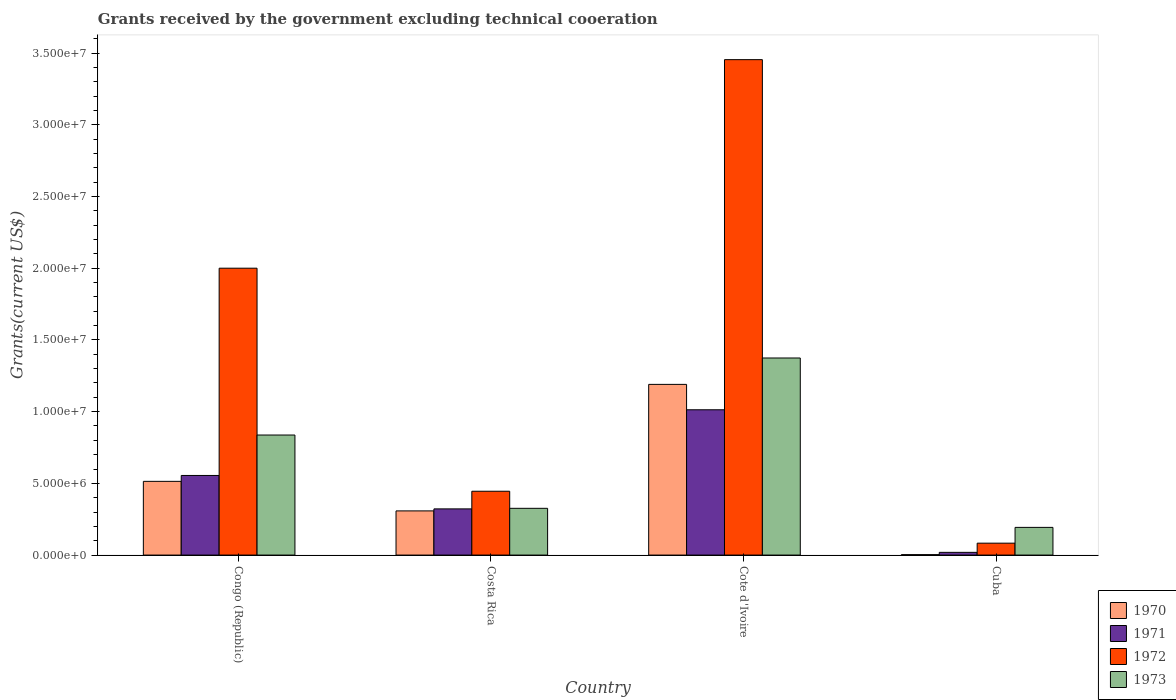Are the number of bars per tick equal to the number of legend labels?
Give a very brief answer. Yes. How many bars are there on the 4th tick from the right?
Your answer should be very brief. 4. What is the label of the 4th group of bars from the left?
Make the answer very short. Cuba. In how many cases, is the number of bars for a given country not equal to the number of legend labels?
Give a very brief answer. 0. What is the total grants received by the government in 1972 in Congo (Republic)?
Provide a short and direct response. 2.00e+07. Across all countries, what is the maximum total grants received by the government in 1972?
Offer a terse response. 3.45e+07. Across all countries, what is the minimum total grants received by the government in 1971?
Your answer should be compact. 1.90e+05. In which country was the total grants received by the government in 1971 maximum?
Make the answer very short. Cote d'Ivoire. In which country was the total grants received by the government in 1970 minimum?
Your answer should be compact. Cuba. What is the total total grants received by the government in 1970 in the graph?
Ensure brevity in your answer.  2.02e+07. What is the difference between the total grants received by the government in 1971 in Costa Rica and that in Cuba?
Your response must be concise. 3.03e+06. What is the difference between the total grants received by the government in 1972 in Costa Rica and the total grants received by the government in 1973 in Cuba?
Make the answer very short. 2.52e+06. What is the average total grants received by the government in 1970 per country?
Give a very brief answer. 5.04e+06. What is the difference between the total grants received by the government of/in 1972 and total grants received by the government of/in 1970 in Congo (Republic)?
Your response must be concise. 1.49e+07. What is the ratio of the total grants received by the government in 1972 in Costa Rica to that in Cuba?
Provide a succinct answer. 5.36. Is the total grants received by the government in 1973 in Congo (Republic) less than that in Costa Rica?
Make the answer very short. No. What is the difference between the highest and the second highest total grants received by the government in 1972?
Keep it short and to the point. 1.45e+07. What is the difference between the highest and the lowest total grants received by the government in 1972?
Keep it short and to the point. 3.37e+07. What does the 3rd bar from the left in Cuba represents?
Give a very brief answer. 1972. What does the 2nd bar from the right in Cote d'Ivoire represents?
Provide a succinct answer. 1972. Is it the case that in every country, the sum of the total grants received by the government in 1971 and total grants received by the government in 1973 is greater than the total grants received by the government in 1972?
Provide a short and direct response. No. How many bars are there?
Ensure brevity in your answer.  16. Are all the bars in the graph horizontal?
Provide a short and direct response. No. How many countries are there in the graph?
Your answer should be very brief. 4. Does the graph contain any zero values?
Provide a succinct answer. No. Does the graph contain grids?
Ensure brevity in your answer.  No. Where does the legend appear in the graph?
Offer a very short reply. Bottom right. How many legend labels are there?
Your answer should be compact. 4. How are the legend labels stacked?
Your answer should be compact. Vertical. What is the title of the graph?
Offer a terse response. Grants received by the government excluding technical cooeration. Does "2002" appear as one of the legend labels in the graph?
Provide a succinct answer. No. What is the label or title of the Y-axis?
Keep it short and to the point. Grants(current US$). What is the Grants(current US$) in 1970 in Congo (Republic)?
Offer a very short reply. 5.14e+06. What is the Grants(current US$) of 1971 in Congo (Republic)?
Make the answer very short. 5.55e+06. What is the Grants(current US$) of 1973 in Congo (Republic)?
Offer a very short reply. 8.37e+06. What is the Grants(current US$) in 1970 in Costa Rica?
Make the answer very short. 3.08e+06. What is the Grants(current US$) in 1971 in Costa Rica?
Keep it short and to the point. 3.22e+06. What is the Grants(current US$) in 1972 in Costa Rica?
Provide a short and direct response. 4.45e+06. What is the Grants(current US$) of 1973 in Costa Rica?
Provide a short and direct response. 3.26e+06. What is the Grants(current US$) of 1970 in Cote d'Ivoire?
Your answer should be compact. 1.19e+07. What is the Grants(current US$) of 1971 in Cote d'Ivoire?
Keep it short and to the point. 1.01e+07. What is the Grants(current US$) of 1972 in Cote d'Ivoire?
Offer a very short reply. 3.45e+07. What is the Grants(current US$) in 1973 in Cote d'Ivoire?
Offer a very short reply. 1.37e+07. What is the Grants(current US$) of 1971 in Cuba?
Offer a very short reply. 1.90e+05. What is the Grants(current US$) in 1972 in Cuba?
Keep it short and to the point. 8.30e+05. What is the Grants(current US$) in 1973 in Cuba?
Your response must be concise. 1.93e+06. Across all countries, what is the maximum Grants(current US$) in 1970?
Keep it short and to the point. 1.19e+07. Across all countries, what is the maximum Grants(current US$) of 1971?
Ensure brevity in your answer.  1.01e+07. Across all countries, what is the maximum Grants(current US$) of 1972?
Your answer should be compact. 3.45e+07. Across all countries, what is the maximum Grants(current US$) in 1973?
Your answer should be very brief. 1.37e+07. Across all countries, what is the minimum Grants(current US$) of 1971?
Keep it short and to the point. 1.90e+05. Across all countries, what is the minimum Grants(current US$) of 1972?
Provide a succinct answer. 8.30e+05. Across all countries, what is the minimum Grants(current US$) of 1973?
Give a very brief answer. 1.93e+06. What is the total Grants(current US$) in 1970 in the graph?
Keep it short and to the point. 2.02e+07. What is the total Grants(current US$) in 1971 in the graph?
Provide a succinct answer. 1.91e+07. What is the total Grants(current US$) in 1972 in the graph?
Offer a terse response. 5.98e+07. What is the total Grants(current US$) in 1973 in the graph?
Your answer should be compact. 2.73e+07. What is the difference between the Grants(current US$) in 1970 in Congo (Republic) and that in Costa Rica?
Your answer should be very brief. 2.06e+06. What is the difference between the Grants(current US$) of 1971 in Congo (Republic) and that in Costa Rica?
Your answer should be very brief. 2.33e+06. What is the difference between the Grants(current US$) of 1972 in Congo (Republic) and that in Costa Rica?
Provide a short and direct response. 1.56e+07. What is the difference between the Grants(current US$) of 1973 in Congo (Republic) and that in Costa Rica?
Give a very brief answer. 5.11e+06. What is the difference between the Grants(current US$) in 1970 in Congo (Republic) and that in Cote d'Ivoire?
Offer a terse response. -6.76e+06. What is the difference between the Grants(current US$) in 1971 in Congo (Republic) and that in Cote d'Ivoire?
Ensure brevity in your answer.  -4.58e+06. What is the difference between the Grants(current US$) in 1972 in Congo (Republic) and that in Cote d'Ivoire?
Give a very brief answer. -1.45e+07. What is the difference between the Grants(current US$) in 1973 in Congo (Republic) and that in Cote d'Ivoire?
Make the answer very short. -5.37e+06. What is the difference between the Grants(current US$) in 1970 in Congo (Republic) and that in Cuba?
Give a very brief answer. 5.11e+06. What is the difference between the Grants(current US$) of 1971 in Congo (Republic) and that in Cuba?
Offer a terse response. 5.36e+06. What is the difference between the Grants(current US$) in 1972 in Congo (Republic) and that in Cuba?
Offer a very short reply. 1.92e+07. What is the difference between the Grants(current US$) in 1973 in Congo (Republic) and that in Cuba?
Your response must be concise. 6.44e+06. What is the difference between the Grants(current US$) in 1970 in Costa Rica and that in Cote d'Ivoire?
Ensure brevity in your answer.  -8.82e+06. What is the difference between the Grants(current US$) in 1971 in Costa Rica and that in Cote d'Ivoire?
Your response must be concise. -6.91e+06. What is the difference between the Grants(current US$) of 1972 in Costa Rica and that in Cote d'Ivoire?
Make the answer very short. -3.01e+07. What is the difference between the Grants(current US$) in 1973 in Costa Rica and that in Cote d'Ivoire?
Keep it short and to the point. -1.05e+07. What is the difference between the Grants(current US$) in 1970 in Costa Rica and that in Cuba?
Make the answer very short. 3.05e+06. What is the difference between the Grants(current US$) of 1971 in Costa Rica and that in Cuba?
Provide a succinct answer. 3.03e+06. What is the difference between the Grants(current US$) in 1972 in Costa Rica and that in Cuba?
Offer a terse response. 3.62e+06. What is the difference between the Grants(current US$) in 1973 in Costa Rica and that in Cuba?
Keep it short and to the point. 1.33e+06. What is the difference between the Grants(current US$) of 1970 in Cote d'Ivoire and that in Cuba?
Offer a terse response. 1.19e+07. What is the difference between the Grants(current US$) of 1971 in Cote d'Ivoire and that in Cuba?
Your answer should be compact. 9.94e+06. What is the difference between the Grants(current US$) of 1972 in Cote d'Ivoire and that in Cuba?
Ensure brevity in your answer.  3.37e+07. What is the difference between the Grants(current US$) in 1973 in Cote d'Ivoire and that in Cuba?
Your response must be concise. 1.18e+07. What is the difference between the Grants(current US$) in 1970 in Congo (Republic) and the Grants(current US$) in 1971 in Costa Rica?
Provide a short and direct response. 1.92e+06. What is the difference between the Grants(current US$) of 1970 in Congo (Republic) and the Grants(current US$) of 1972 in Costa Rica?
Your answer should be very brief. 6.90e+05. What is the difference between the Grants(current US$) of 1970 in Congo (Republic) and the Grants(current US$) of 1973 in Costa Rica?
Your response must be concise. 1.88e+06. What is the difference between the Grants(current US$) of 1971 in Congo (Republic) and the Grants(current US$) of 1972 in Costa Rica?
Ensure brevity in your answer.  1.10e+06. What is the difference between the Grants(current US$) of 1971 in Congo (Republic) and the Grants(current US$) of 1973 in Costa Rica?
Offer a terse response. 2.29e+06. What is the difference between the Grants(current US$) in 1972 in Congo (Republic) and the Grants(current US$) in 1973 in Costa Rica?
Provide a short and direct response. 1.67e+07. What is the difference between the Grants(current US$) of 1970 in Congo (Republic) and the Grants(current US$) of 1971 in Cote d'Ivoire?
Your response must be concise. -4.99e+06. What is the difference between the Grants(current US$) of 1970 in Congo (Republic) and the Grants(current US$) of 1972 in Cote d'Ivoire?
Give a very brief answer. -2.94e+07. What is the difference between the Grants(current US$) in 1970 in Congo (Republic) and the Grants(current US$) in 1973 in Cote d'Ivoire?
Your answer should be compact. -8.60e+06. What is the difference between the Grants(current US$) of 1971 in Congo (Republic) and the Grants(current US$) of 1972 in Cote d'Ivoire?
Offer a terse response. -2.90e+07. What is the difference between the Grants(current US$) in 1971 in Congo (Republic) and the Grants(current US$) in 1973 in Cote d'Ivoire?
Give a very brief answer. -8.19e+06. What is the difference between the Grants(current US$) of 1972 in Congo (Republic) and the Grants(current US$) of 1973 in Cote d'Ivoire?
Offer a very short reply. 6.26e+06. What is the difference between the Grants(current US$) of 1970 in Congo (Republic) and the Grants(current US$) of 1971 in Cuba?
Keep it short and to the point. 4.95e+06. What is the difference between the Grants(current US$) of 1970 in Congo (Republic) and the Grants(current US$) of 1972 in Cuba?
Provide a succinct answer. 4.31e+06. What is the difference between the Grants(current US$) of 1970 in Congo (Republic) and the Grants(current US$) of 1973 in Cuba?
Make the answer very short. 3.21e+06. What is the difference between the Grants(current US$) of 1971 in Congo (Republic) and the Grants(current US$) of 1972 in Cuba?
Your answer should be compact. 4.72e+06. What is the difference between the Grants(current US$) in 1971 in Congo (Republic) and the Grants(current US$) in 1973 in Cuba?
Ensure brevity in your answer.  3.62e+06. What is the difference between the Grants(current US$) of 1972 in Congo (Republic) and the Grants(current US$) of 1973 in Cuba?
Make the answer very short. 1.81e+07. What is the difference between the Grants(current US$) of 1970 in Costa Rica and the Grants(current US$) of 1971 in Cote d'Ivoire?
Give a very brief answer. -7.05e+06. What is the difference between the Grants(current US$) in 1970 in Costa Rica and the Grants(current US$) in 1972 in Cote d'Ivoire?
Make the answer very short. -3.15e+07. What is the difference between the Grants(current US$) of 1970 in Costa Rica and the Grants(current US$) of 1973 in Cote d'Ivoire?
Provide a succinct answer. -1.07e+07. What is the difference between the Grants(current US$) in 1971 in Costa Rica and the Grants(current US$) in 1972 in Cote d'Ivoire?
Your answer should be compact. -3.13e+07. What is the difference between the Grants(current US$) in 1971 in Costa Rica and the Grants(current US$) in 1973 in Cote d'Ivoire?
Provide a short and direct response. -1.05e+07. What is the difference between the Grants(current US$) in 1972 in Costa Rica and the Grants(current US$) in 1973 in Cote d'Ivoire?
Offer a terse response. -9.29e+06. What is the difference between the Grants(current US$) in 1970 in Costa Rica and the Grants(current US$) in 1971 in Cuba?
Your answer should be very brief. 2.89e+06. What is the difference between the Grants(current US$) in 1970 in Costa Rica and the Grants(current US$) in 1972 in Cuba?
Offer a terse response. 2.25e+06. What is the difference between the Grants(current US$) of 1970 in Costa Rica and the Grants(current US$) of 1973 in Cuba?
Your answer should be very brief. 1.15e+06. What is the difference between the Grants(current US$) in 1971 in Costa Rica and the Grants(current US$) in 1972 in Cuba?
Your answer should be compact. 2.39e+06. What is the difference between the Grants(current US$) of 1971 in Costa Rica and the Grants(current US$) of 1973 in Cuba?
Your response must be concise. 1.29e+06. What is the difference between the Grants(current US$) of 1972 in Costa Rica and the Grants(current US$) of 1973 in Cuba?
Your response must be concise. 2.52e+06. What is the difference between the Grants(current US$) of 1970 in Cote d'Ivoire and the Grants(current US$) of 1971 in Cuba?
Your answer should be compact. 1.17e+07. What is the difference between the Grants(current US$) of 1970 in Cote d'Ivoire and the Grants(current US$) of 1972 in Cuba?
Ensure brevity in your answer.  1.11e+07. What is the difference between the Grants(current US$) of 1970 in Cote d'Ivoire and the Grants(current US$) of 1973 in Cuba?
Offer a very short reply. 9.97e+06. What is the difference between the Grants(current US$) of 1971 in Cote d'Ivoire and the Grants(current US$) of 1972 in Cuba?
Provide a succinct answer. 9.30e+06. What is the difference between the Grants(current US$) in 1971 in Cote d'Ivoire and the Grants(current US$) in 1973 in Cuba?
Provide a short and direct response. 8.20e+06. What is the difference between the Grants(current US$) in 1972 in Cote d'Ivoire and the Grants(current US$) in 1973 in Cuba?
Your answer should be very brief. 3.26e+07. What is the average Grants(current US$) in 1970 per country?
Your answer should be very brief. 5.04e+06. What is the average Grants(current US$) in 1971 per country?
Provide a short and direct response. 4.77e+06. What is the average Grants(current US$) of 1972 per country?
Your answer should be compact. 1.50e+07. What is the average Grants(current US$) of 1973 per country?
Provide a succinct answer. 6.82e+06. What is the difference between the Grants(current US$) in 1970 and Grants(current US$) in 1971 in Congo (Republic)?
Your answer should be very brief. -4.10e+05. What is the difference between the Grants(current US$) in 1970 and Grants(current US$) in 1972 in Congo (Republic)?
Provide a short and direct response. -1.49e+07. What is the difference between the Grants(current US$) of 1970 and Grants(current US$) of 1973 in Congo (Republic)?
Make the answer very short. -3.23e+06. What is the difference between the Grants(current US$) in 1971 and Grants(current US$) in 1972 in Congo (Republic)?
Ensure brevity in your answer.  -1.44e+07. What is the difference between the Grants(current US$) of 1971 and Grants(current US$) of 1973 in Congo (Republic)?
Offer a very short reply. -2.82e+06. What is the difference between the Grants(current US$) of 1972 and Grants(current US$) of 1973 in Congo (Republic)?
Make the answer very short. 1.16e+07. What is the difference between the Grants(current US$) in 1970 and Grants(current US$) in 1971 in Costa Rica?
Provide a succinct answer. -1.40e+05. What is the difference between the Grants(current US$) in 1970 and Grants(current US$) in 1972 in Costa Rica?
Offer a terse response. -1.37e+06. What is the difference between the Grants(current US$) of 1970 and Grants(current US$) of 1973 in Costa Rica?
Keep it short and to the point. -1.80e+05. What is the difference between the Grants(current US$) in 1971 and Grants(current US$) in 1972 in Costa Rica?
Your answer should be compact. -1.23e+06. What is the difference between the Grants(current US$) in 1971 and Grants(current US$) in 1973 in Costa Rica?
Give a very brief answer. -4.00e+04. What is the difference between the Grants(current US$) of 1972 and Grants(current US$) of 1973 in Costa Rica?
Your response must be concise. 1.19e+06. What is the difference between the Grants(current US$) in 1970 and Grants(current US$) in 1971 in Cote d'Ivoire?
Offer a terse response. 1.77e+06. What is the difference between the Grants(current US$) in 1970 and Grants(current US$) in 1972 in Cote d'Ivoire?
Your answer should be very brief. -2.26e+07. What is the difference between the Grants(current US$) in 1970 and Grants(current US$) in 1973 in Cote d'Ivoire?
Provide a succinct answer. -1.84e+06. What is the difference between the Grants(current US$) in 1971 and Grants(current US$) in 1972 in Cote d'Ivoire?
Your answer should be compact. -2.44e+07. What is the difference between the Grants(current US$) of 1971 and Grants(current US$) of 1973 in Cote d'Ivoire?
Keep it short and to the point. -3.61e+06. What is the difference between the Grants(current US$) in 1972 and Grants(current US$) in 1973 in Cote d'Ivoire?
Provide a short and direct response. 2.08e+07. What is the difference between the Grants(current US$) of 1970 and Grants(current US$) of 1971 in Cuba?
Your answer should be compact. -1.60e+05. What is the difference between the Grants(current US$) of 1970 and Grants(current US$) of 1972 in Cuba?
Give a very brief answer. -8.00e+05. What is the difference between the Grants(current US$) in 1970 and Grants(current US$) in 1973 in Cuba?
Your answer should be very brief. -1.90e+06. What is the difference between the Grants(current US$) of 1971 and Grants(current US$) of 1972 in Cuba?
Ensure brevity in your answer.  -6.40e+05. What is the difference between the Grants(current US$) in 1971 and Grants(current US$) in 1973 in Cuba?
Provide a succinct answer. -1.74e+06. What is the difference between the Grants(current US$) of 1972 and Grants(current US$) of 1973 in Cuba?
Offer a terse response. -1.10e+06. What is the ratio of the Grants(current US$) of 1970 in Congo (Republic) to that in Costa Rica?
Your answer should be compact. 1.67. What is the ratio of the Grants(current US$) in 1971 in Congo (Republic) to that in Costa Rica?
Your response must be concise. 1.72. What is the ratio of the Grants(current US$) of 1972 in Congo (Republic) to that in Costa Rica?
Keep it short and to the point. 4.49. What is the ratio of the Grants(current US$) in 1973 in Congo (Republic) to that in Costa Rica?
Offer a very short reply. 2.57. What is the ratio of the Grants(current US$) of 1970 in Congo (Republic) to that in Cote d'Ivoire?
Your response must be concise. 0.43. What is the ratio of the Grants(current US$) in 1971 in Congo (Republic) to that in Cote d'Ivoire?
Provide a succinct answer. 0.55. What is the ratio of the Grants(current US$) in 1972 in Congo (Republic) to that in Cote d'Ivoire?
Keep it short and to the point. 0.58. What is the ratio of the Grants(current US$) in 1973 in Congo (Republic) to that in Cote d'Ivoire?
Provide a succinct answer. 0.61. What is the ratio of the Grants(current US$) in 1970 in Congo (Republic) to that in Cuba?
Ensure brevity in your answer.  171.33. What is the ratio of the Grants(current US$) in 1971 in Congo (Republic) to that in Cuba?
Your answer should be very brief. 29.21. What is the ratio of the Grants(current US$) in 1972 in Congo (Republic) to that in Cuba?
Ensure brevity in your answer.  24.1. What is the ratio of the Grants(current US$) of 1973 in Congo (Republic) to that in Cuba?
Your answer should be very brief. 4.34. What is the ratio of the Grants(current US$) of 1970 in Costa Rica to that in Cote d'Ivoire?
Make the answer very short. 0.26. What is the ratio of the Grants(current US$) in 1971 in Costa Rica to that in Cote d'Ivoire?
Your answer should be compact. 0.32. What is the ratio of the Grants(current US$) of 1972 in Costa Rica to that in Cote d'Ivoire?
Offer a terse response. 0.13. What is the ratio of the Grants(current US$) in 1973 in Costa Rica to that in Cote d'Ivoire?
Give a very brief answer. 0.24. What is the ratio of the Grants(current US$) in 1970 in Costa Rica to that in Cuba?
Your answer should be very brief. 102.67. What is the ratio of the Grants(current US$) of 1971 in Costa Rica to that in Cuba?
Make the answer very short. 16.95. What is the ratio of the Grants(current US$) in 1972 in Costa Rica to that in Cuba?
Give a very brief answer. 5.36. What is the ratio of the Grants(current US$) in 1973 in Costa Rica to that in Cuba?
Ensure brevity in your answer.  1.69. What is the ratio of the Grants(current US$) of 1970 in Cote d'Ivoire to that in Cuba?
Your answer should be compact. 396.67. What is the ratio of the Grants(current US$) of 1971 in Cote d'Ivoire to that in Cuba?
Provide a succinct answer. 53.32. What is the ratio of the Grants(current US$) of 1972 in Cote d'Ivoire to that in Cuba?
Provide a succinct answer. 41.61. What is the ratio of the Grants(current US$) in 1973 in Cote d'Ivoire to that in Cuba?
Offer a terse response. 7.12. What is the difference between the highest and the second highest Grants(current US$) in 1970?
Make the answer very short. 6.76e+06. What is the difference between the highest and the second highest Grants(current US$) of 1971?
Ensure brevity in your answer.  4.58e+06. What is the difference between the highest and the second highest Grants(current US$) in 1972?
Ensure brevity in your answer.  1.45e+07. What is the difference between the highest and the second highest Grants(current US$) of 1973?
Provide a succinct answer. 5.37e+06. What is the difference between the highest and the lowest Grants(current US$) in 1970?
Make the answer very short. 1.19e+07. What is the difference between the highest and the lowest Grants(current US$) of 1971?
Your answer should be compact. 9.94e+06. What is the difference between the highest and the lowest Grants(current US$) of 1972?
Ensure brevity in your answer.  3.37e+07. What is the difference between the highest and the lowest Grants(current US$) in 1973?
Provide a succinct answer. 1.18e+07. 